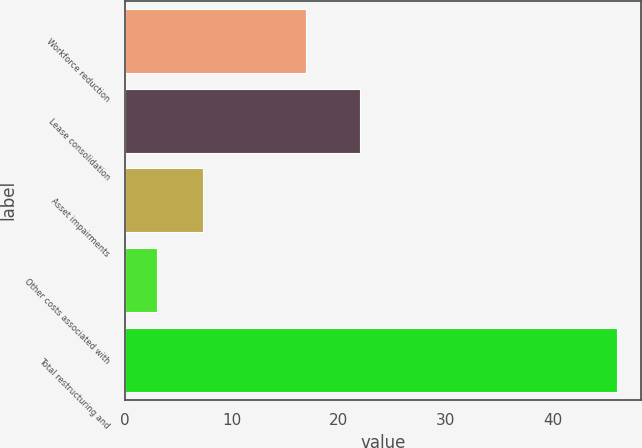<chart> <loc_0><loc_0><loc_500><loc_500><bar_chart><fcel>Workforce reduction<fcel>Lease consolidation<fcel>Asset impairments<fcel>Other costs associated with<fcel>Total restructuring and<nl><fcel>17<fcel>22<fcel>7.3<fcel>3<fcel>46<nl></chart> 